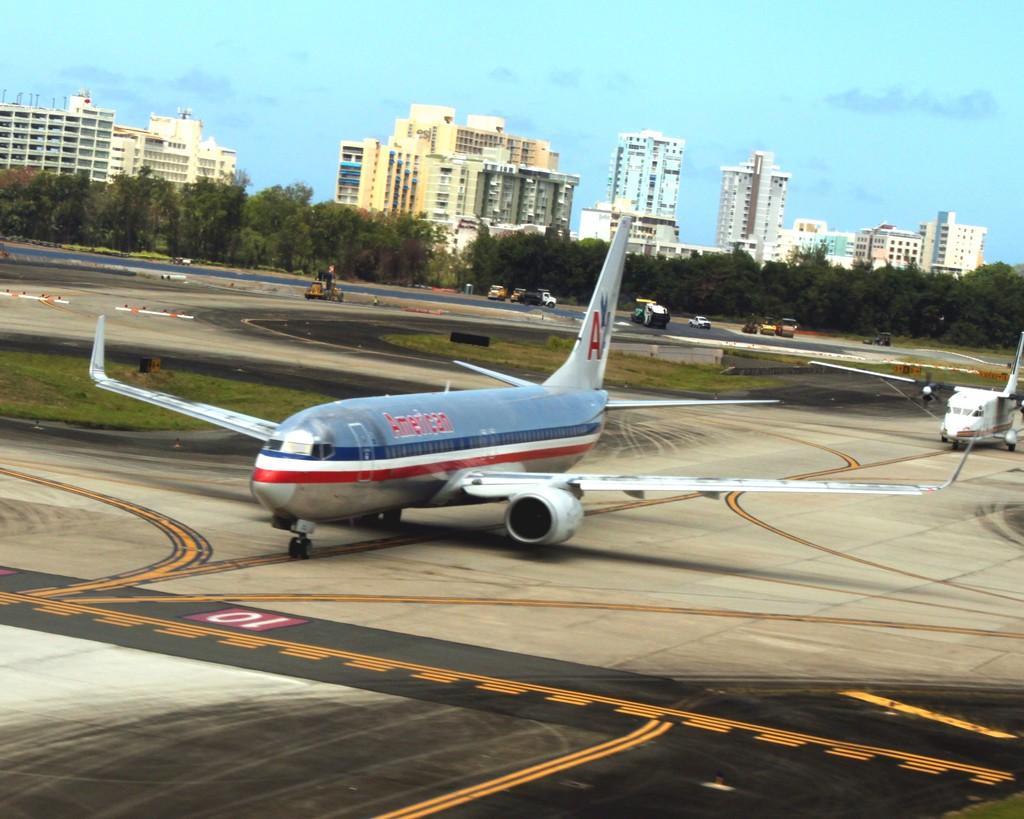Could you give a brief overview of what you see in this image? In this image we can see aeroplanes. In the background there are vehicles on the runway and we can see buildings and trees. At the top there is sky. 